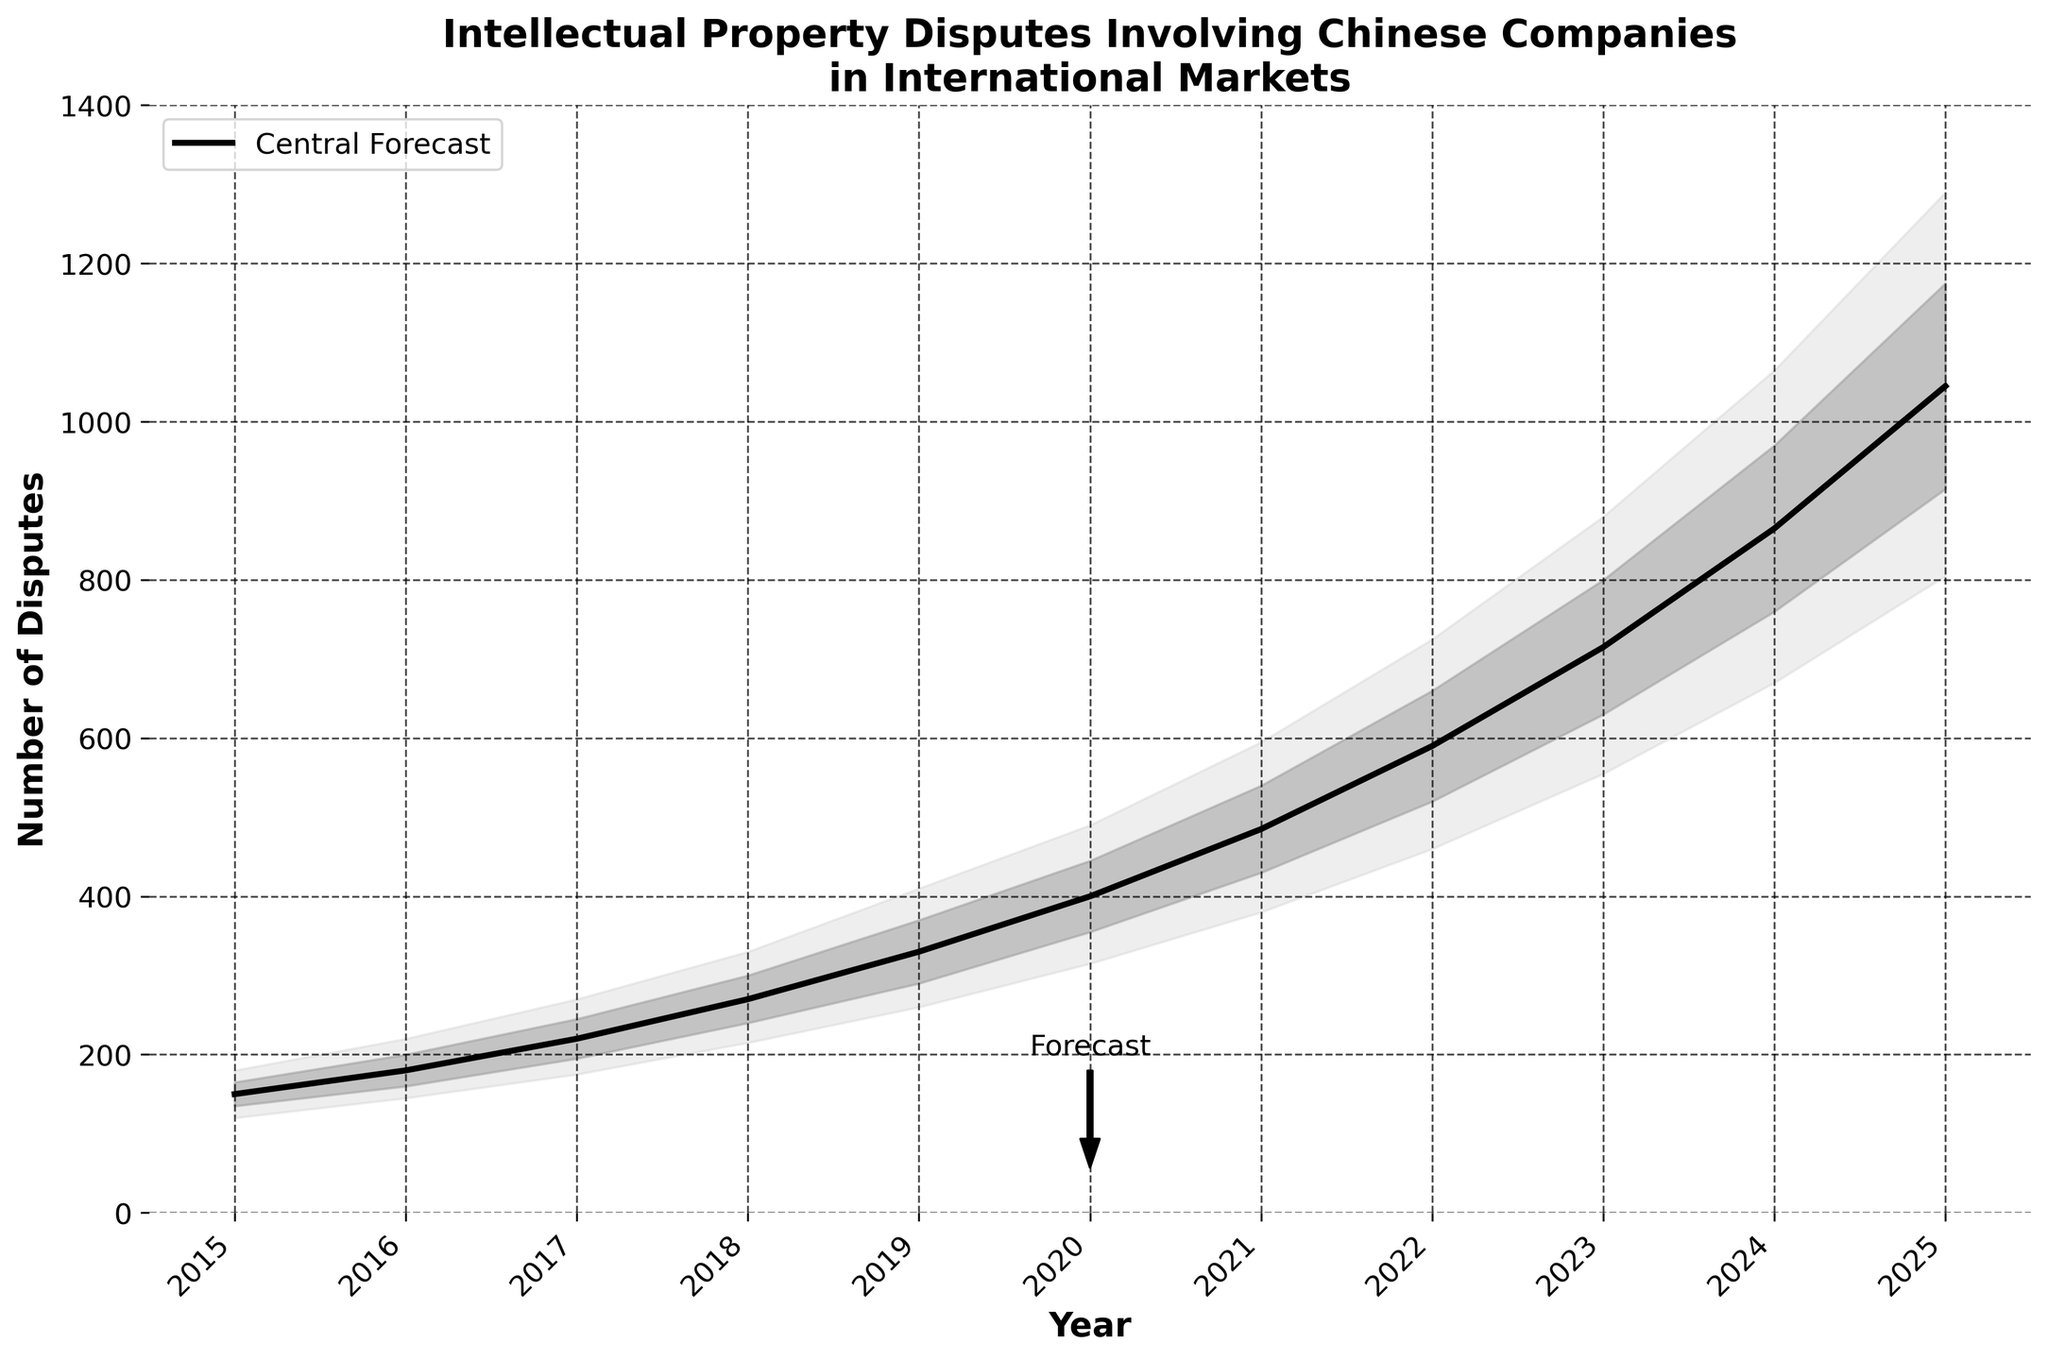What is the title of the figure? The title of the figure is located at the top and provides an overview of the visualization content. According to the provided code, the title is set as 'Intellectual Property Disputes Involving Chinese Companies\nin International Markets'.
Answer: Intellectual Property Disputes Involving Chinese Companies in International Markets Which year has the highest number of intellectual property disputes forecasted for 2025 in the central forecast? To find the highest number of intellectual property disputes forecasted for 2025, look at the ‘Central Forecast’ column corresponding to the year 2025. It is marked as 1045.
Answer: 1045 What are the upper and lower bounds for the number of disputes in 2021 within the 75% confidence interval? The upper bound is found in the 'Upper 75%' while the lower bound is in the 'Lower 25%' for the year 2021. The upper bound is 540, and the lower bound is 430.
Answer: 430 and 540 How does the trend of the central forecast evolve from 2015 to 2025? To determine the trend, observe the values in the 'Central Forecast' column from 2015 to 2025. The numbers show a steady increase yearly, indicating an upward trend.
Answer: Upward trend What is the difference between the upper 90% forecast and the central forecast in 2022? The difference can be calculated by subtracting the central forecast value from the upper 90% value in 2022. The values are 725 (Upper 90%) and 590 (Central Forecast), so the difference is 725 - 590.
Answer: 135 In which year is the forecasted number of disputes closest to 500 in the central forecast? Check the 'Central Forecast' values for each year to find the one closest to 500. The closest value is 485 in the year 2021.
Answer: 2021 How much did the central forecast increase from 2019 to 2020? The increase can be found by subtracting the central forecast of 2019 from that of 2020. The values are 400 (2020) and 330 (2019), so the increase is 400 - 330.
Answer: 70 Between which years does the largest increase in the central forecast occur? Calculate the yearly increases from the 'Central Forecast' column and identify the largest one. The increase from 2018 (270) to 2019 (330) is 60, while from 2021 (485) to 2022 (590) is 105, and the largest increase occurs between 2021 and 2022.
Answer: 2021 and 2022 What forecast (within the 90% confidence interval) is predicted for the year immediately after the annotated 'Forecast' arrow? The 'Forecast' annotation points to 2020. Within the 90% interval for 2021 (immediately after), the range from lower 10% (380) to upper 90% (595) is given.
Answer: 380 to 595 